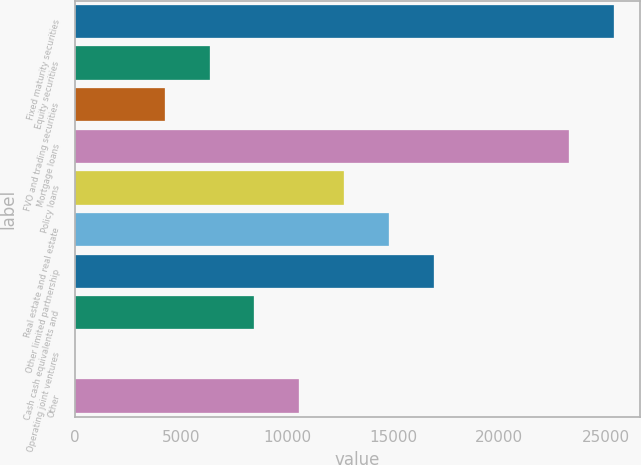Convert chart to OTSL. <chart><loc_0><loc_0><loc_500><loc_500><bar_chart><fcel>Fixed maturity securities<fcel>Equity securities<fcel>FVO and trading securities<fcel>Mortgage loans<fcel>Policy loans<fcel>Real estate and real estate<fcel>Other limited partnership<fcel>Cash cash equivalents and<fcel>Operating joint ventures<fcel>Other<nl><fcel>25381.6<fcel>6352.9<fcel>4238.6<fcel>23267.3<fcel>12695.8<fcel>14810.1<fcel>16924.4<fcel>8467.2<fcel>10<fcel>10581.5<nl></chart> 